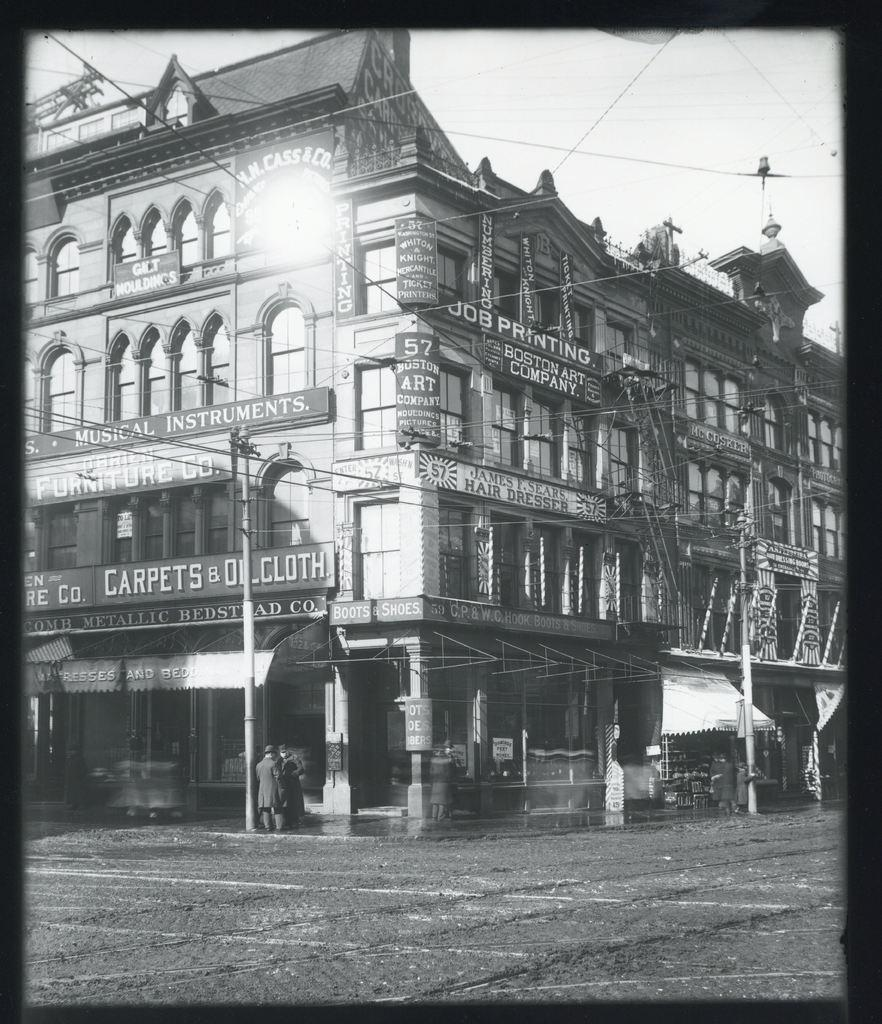What can be seen in the image that is related to infrastructure? There are building poles with wires in the image. What is the person in the image doing? A person is standing on the road in the image. What can be seen in the background of the image? The sky is visible in the background of the image. How is the image presented in terms of color? The image is black and white in color. Is the person in the image a health professional or a lawyer? The image does not provide any information about the person's profession, so we cannot determine if they are a health professional or a lawyer. Can you see a bike in the image? There is no bike present in the image. 